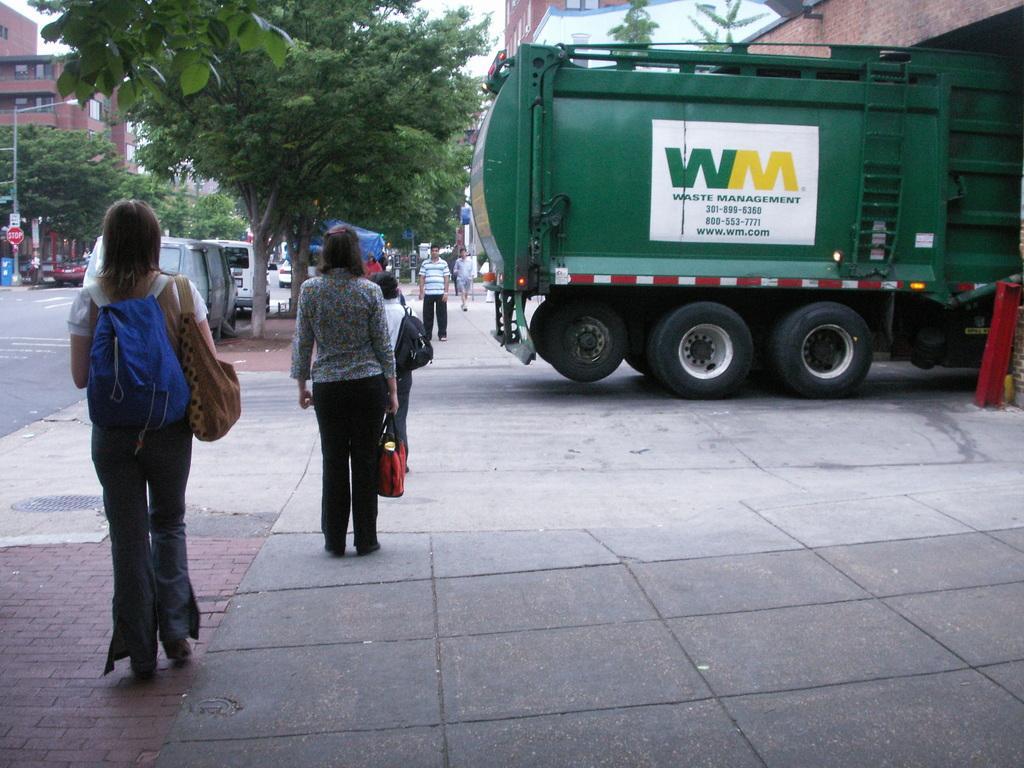Please provide a concise description of this image. In this image there is a vehicle on the pavement. Few people are on the pavement. Left side there is a person carrying the bags. Before there is a woman holding the bag. Few vehicles are on the road. Left side there is a street light. Background there are trees and buildings. 